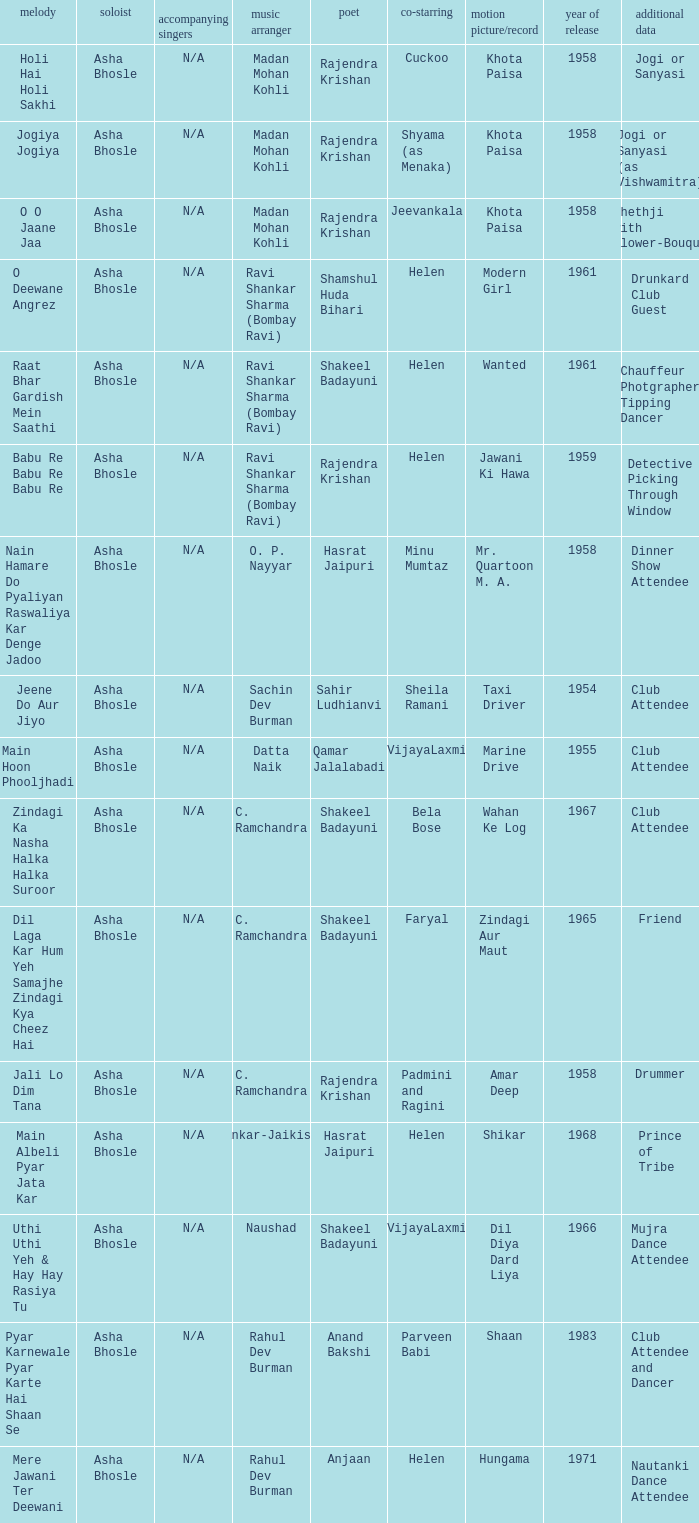Who sang for the movie Amar Deep? Asha Bhosle. 